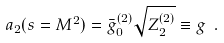<formula> <loc_0><loc_0><loc_500><loc_500>a _ { 2 } ( s = M ^ { 2 } ) = \bar { g } _ { 0 } ^ { ( 2 ) } \sqrt { Z _ { 2 } ^ { ( 2 ) } } \equiv g \ .</formula> 